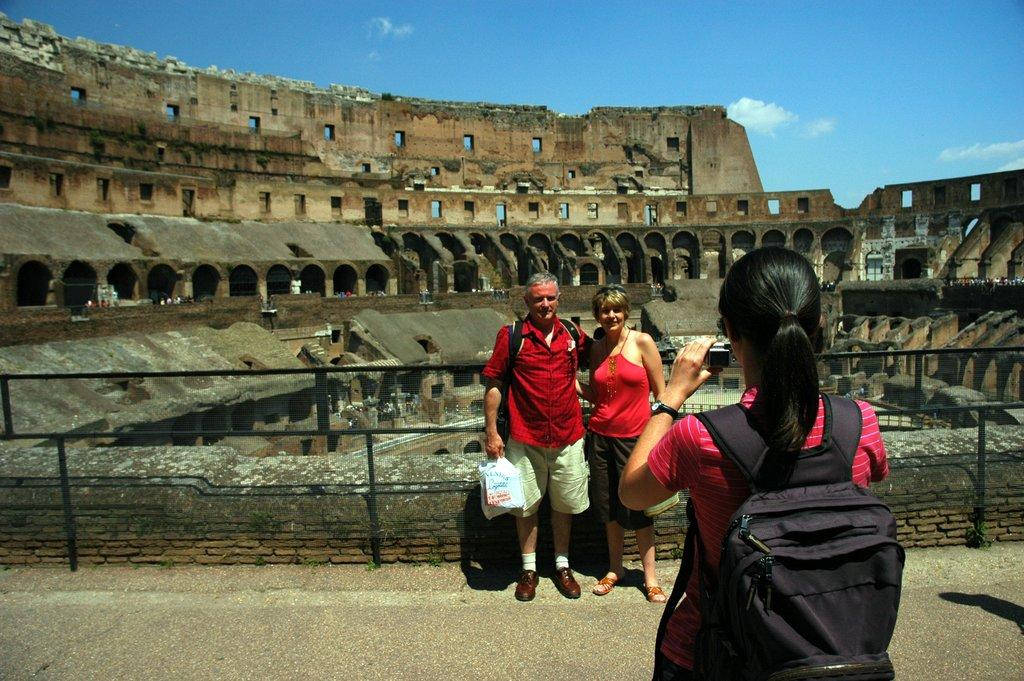How many people are present in the image? There are two people in the image. What are the people doing in the image? A girl is clicking an image of them. What can be seen in the background of the image? There is a historical monument in the background of the image. What type of gold object is visible in the image? There is no gold object present in the image. How many thumbs can be seen in the image? The number of thumbs cannot be determined from the image, as only the girl's hand is visible while she is clicking the image. 